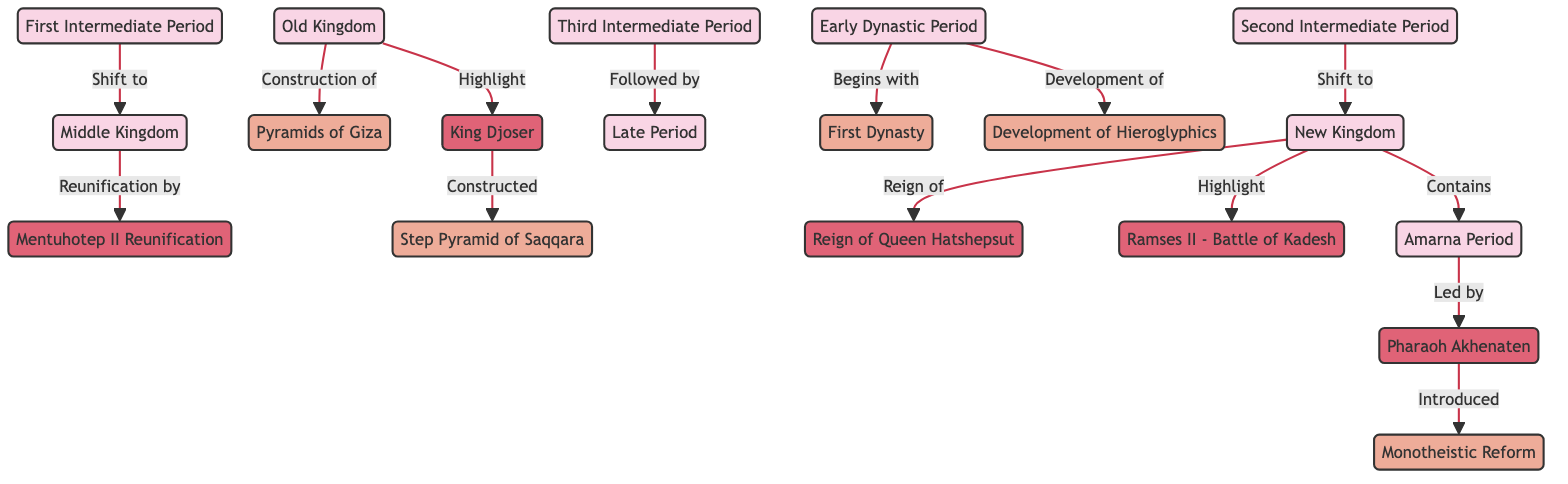What does the Early Dynastic Period develop? From the diagram, it shows that the Early Dynastic Period is connected to the Development of Hieroglyphics, indicating that this was a significant achievement during that time.
Answer: Development of Hieroglyphics Which dynasty is highlighted by the Pyramids of Giza? The Old Kingdom is connected to the Pyramids of Giza through a directed edge labeled "Construction of," suggesting that this period is renowned for these monuments.
Answer: Old Kingdom What follows the Third Intermediate Period? The directed edge indicates that the Late Period comes after the Third Intermediate Period, meaning it is the next historical phase.
Answer: Late Period Who reunifies Egypt during the Middle Kingdom? The connection from the Middle Kingdom to Mentuhotep II through the edge labeled "Reunification by" specifies Mentuhotep II as the key figure responsible for the reunification of Egypt.
Answer: Mentuhotep II What significant event is associated with Ramses II? The edge from New Kingdom to Ramses II labeled "Highlight" signifies a notable achievement or event during his reign, pointing out importance tied to this ruler.
Answer: Battle of Kadesh During which period is the Pharaoh Akhenaten in charge? The edge labeled "Led by" points from Amarna Period to Akhenaten, showing he was the leading figure during this specific period in ancient Egyptian history.
Answer: Amarna Period How many major periods are listed in the diagram? By counting the periods, there are nine nodes labeled as different periods: Early Dynastic Period, Old Kingdom, First Intermediate Period, Middle Kingdom, Second Intermediate Period, New Kingdom, Amarna Period, Third Intermediate Period, Late Period.
Answer: Nine Which achievement is constructed by King Djoser? The edge connecting King Djoser to the Step Pyramid shows that this specific structure was built under his rule, emphasizing his architectural contribution.
Answer: Step Pyramid of Saqqara What reform is introduced by Akhenaten? The structure connecting Akhenaten to Monotheism indicates that he is responsible for introducing the concept of Monotheism during his reign.
Answer: Monotheistic Reform 